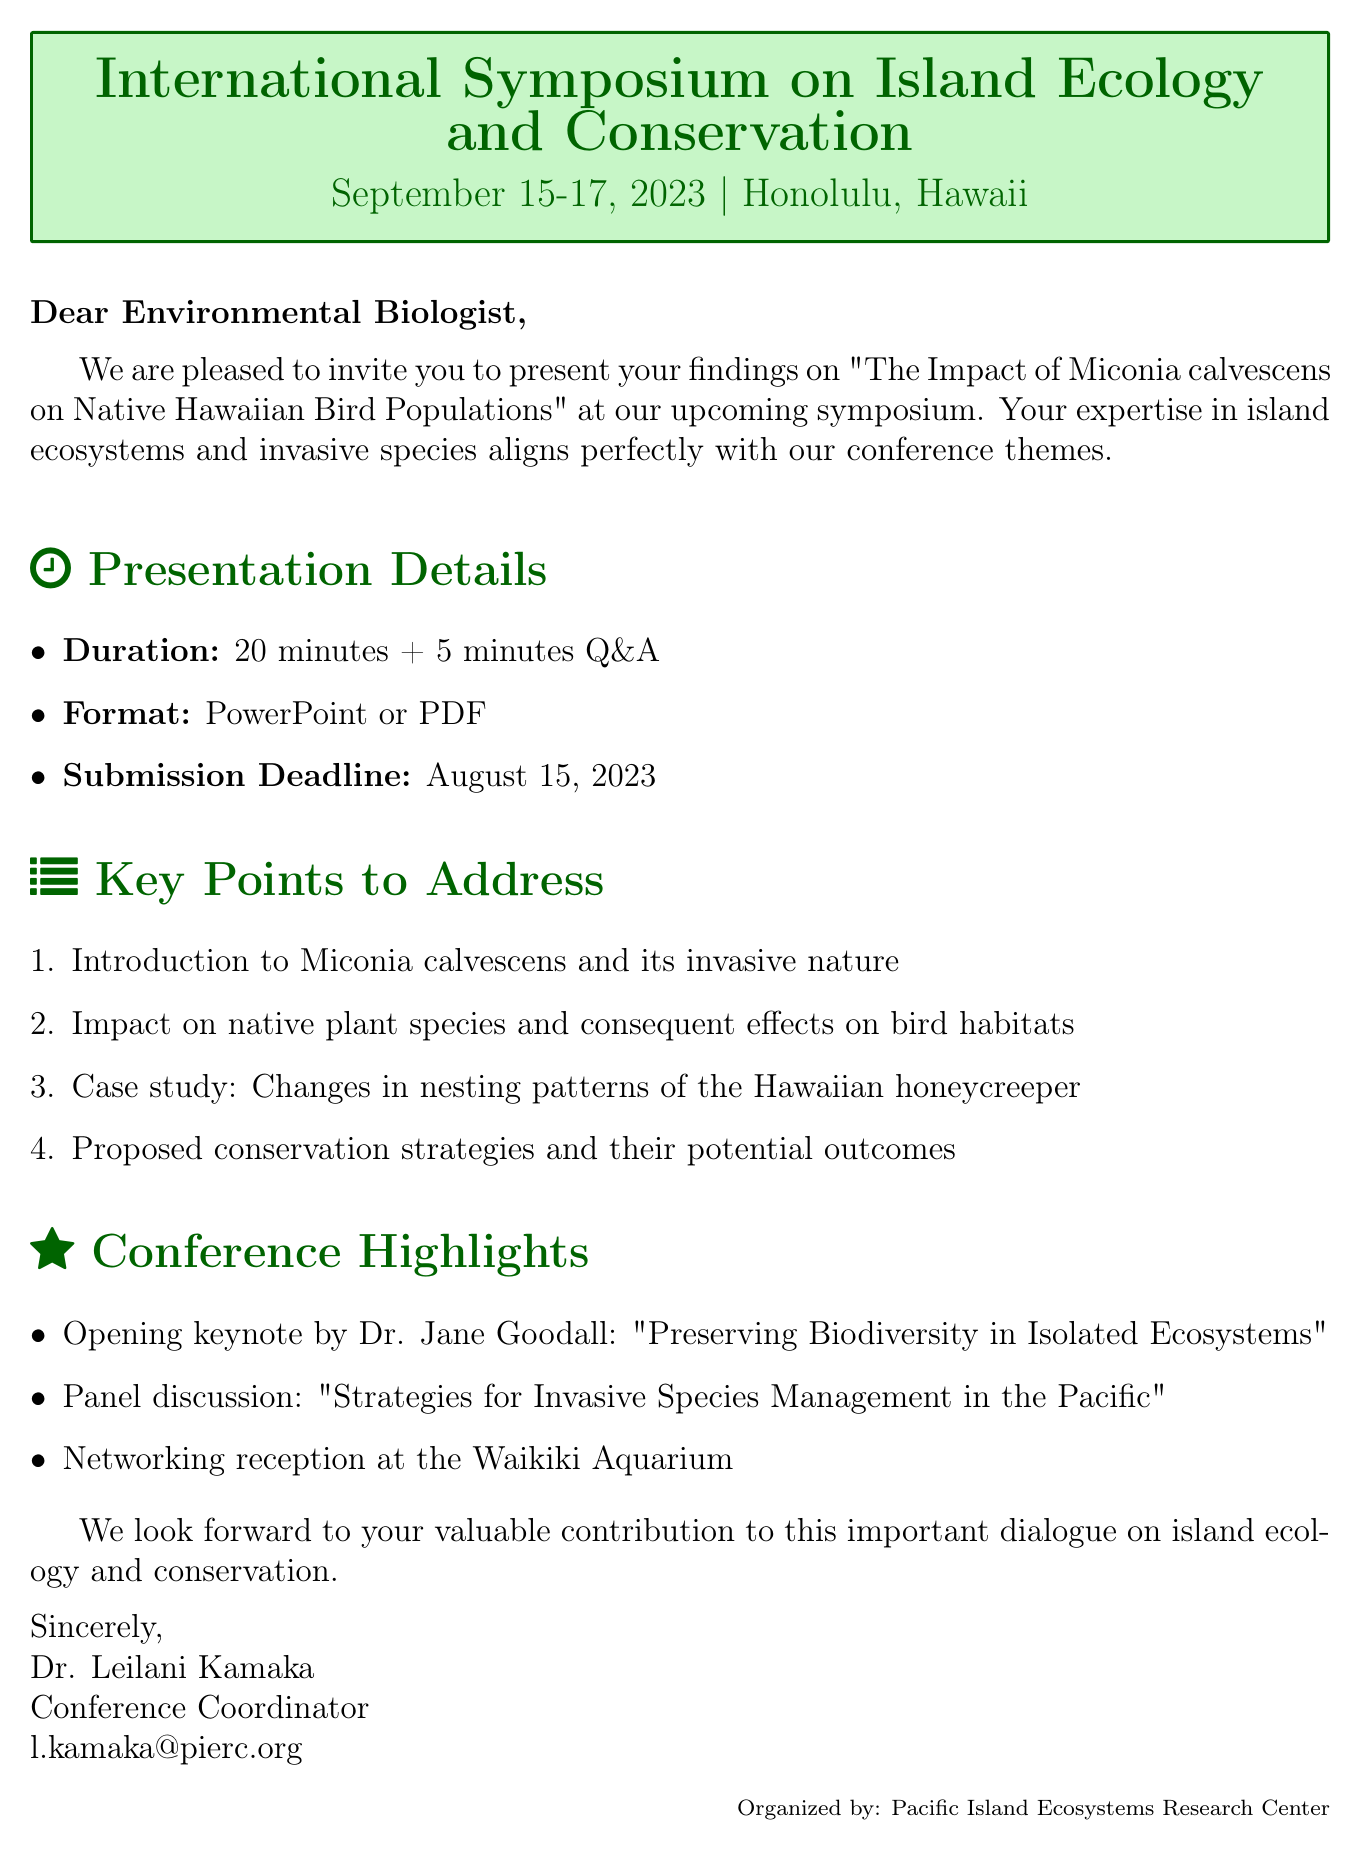What is the name of the conference? The name of the conference is stated at the beginning of the document.
Answer: International Symposium on Island Ecology and Conservation What are the dates of the conference? The dates are mentioned right after the conference name.
Answer: September 15-17, 2023 Where is the conference located? The location of the conference is provided explicitly in the document.
Answer: Honolulu, Hawaii Who is the conference organizer? The organizer's name is mentioned towards the end of the document.
Answer: Pacific Island Ecosystems Research Center What is the submission deadline for the presentation? The submission deadline is clearly stated in the presentation guidelines.
Answer: August 15, 2023 What is the duration of the presentation? The duration is specified in the presentation details section.
Answer: 20 minutes + 5 minutes Q&A What key topic addresses the impact on nesting patterns? A specific key point focuses on the nesting patterns, which is detailed in the key points to address.
Answer: Changes in nesting patterns of the Hawaiian honeycreeper Who is the contact person for the conference? The contact person's name is listed at the end of the email.
Answer: Dr. Leilani Kamaka What is the format for the presentation? The format is specified in the document under presentation details.
Answer: PowerPoint or PDF 